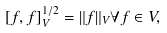<formula> <loc_0><loc_0><loc_500><loc_500>[ f , f ] _ { V } ^ { 1 / 2 } = \| f \| _ { V } \forall f \in V ,</formula> 